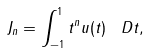<formula> <loc_0><loc_0><loc_500><loc_500>J _ { n } = \int _ { - 1 } ^ { 1 } t ^ { n } u ( t ) \, \ D t ,</formula> 